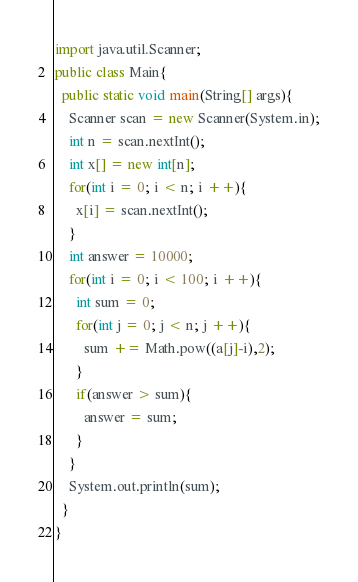<code> <loc_0><loc_0><loc_500><loc_500><_Java_>import java.util.Scanner;
public class Main{
  public static void main(String[] args){
    Scanner scan = new Scanner(System.in);
    int n = scan.nextInt();
    int x[] = new int[n];
    for(int i = 0; i < n; i ++){
      x[i] = scan.nextInt();
    }
    int answer = 10000;
    for(int i = 0; i < 100; i ++){
      int sum = 0;
      for(int j = 0; j < n; j ++){
        sum += Math.pow((a[j]-i),2);
      }
      if(answer > sum){
        answer = sum;
      }
    }
    System.out.println(sum);
  }
}
</code> 